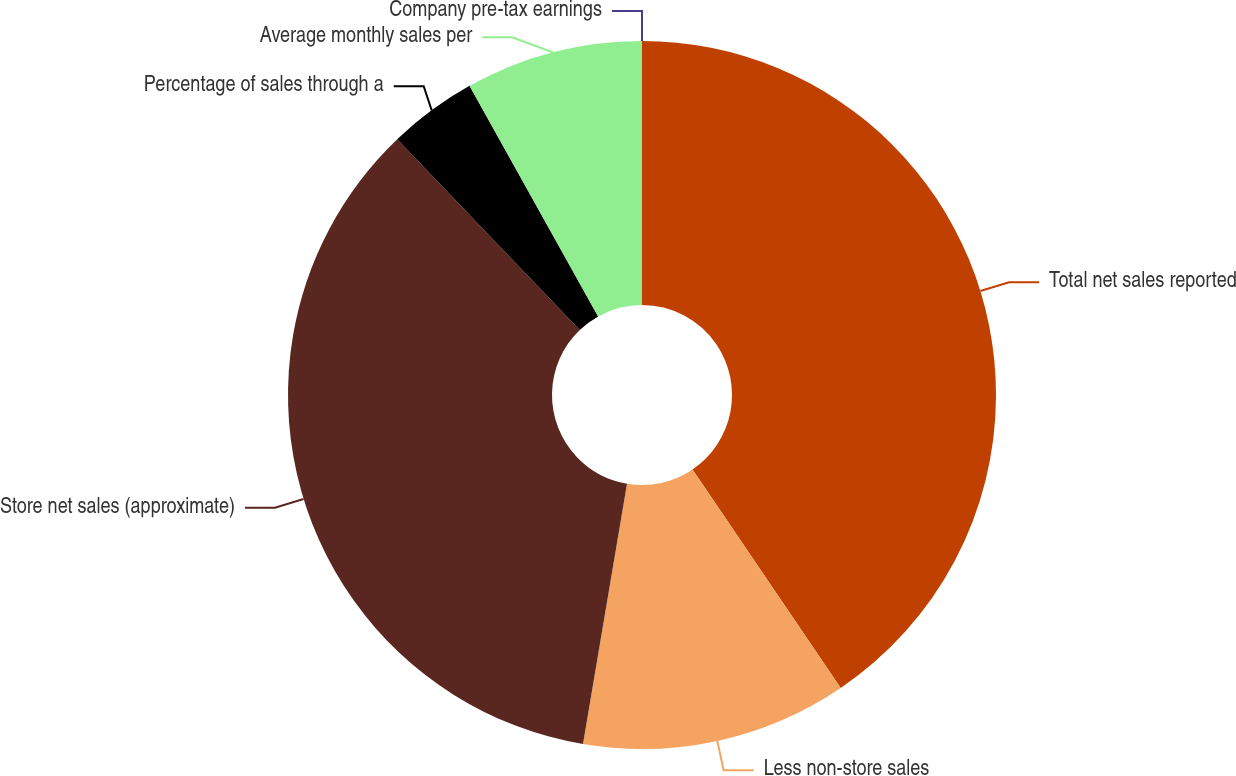<chart> <loc_0><loc_0><loc_500><loc_500><pie_chart><fcel>Total net sales reported<fcel>Less non-store sales<fcel>Store net sales (approximate)<fcel>Percentage of sales through a<fcel>Average monthly sales per<fcel>Company pre-tax earnings<nl><fcel>40.51%<fcel>12.15%<fcel>35.18%<fcel>4.05%<fcel>8.1%<fcel>0.0%<nl></chart> 